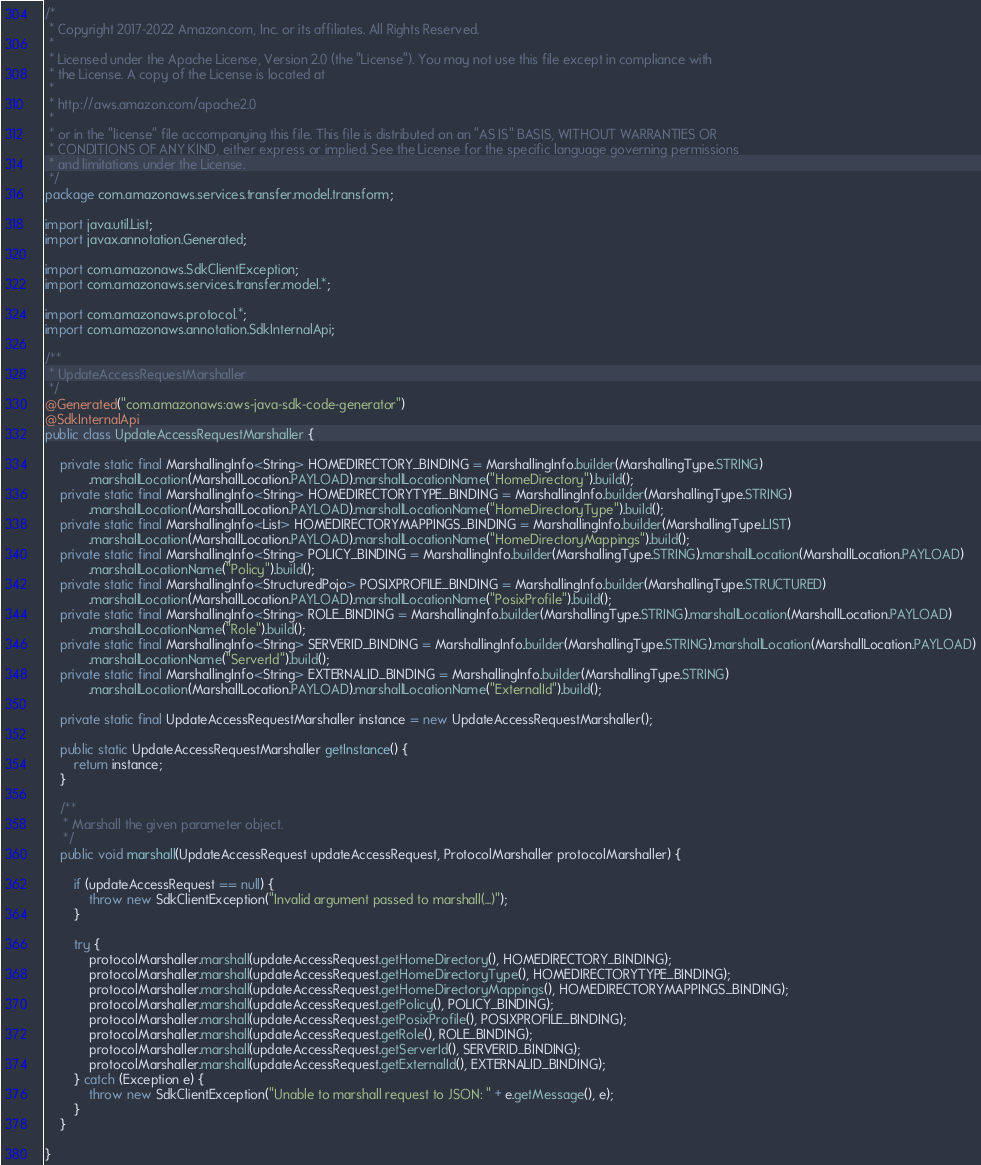<code> <loc_0><loc_0><loc_500><loc_500><_Java_>/*
 * Copyright 2017-2022 Amazon.com, Inc. or its affiliates. All Rights Reserved.
 * 
 * Licensed under the Apache License, Version 2.0 (the "License"). You may not use this file except in compliance with
 * the License. A copy of the License is located at
 * 
 * http://aws.amazon.com/apache2.0
 * 
 * or in the "license" file accompanying this file. This file is distributed on an "AS IS" BASIS, WITHOUT WARRANTIES OR
 * CONDITIONS OF ANY KIND, either express or implied. See the License for the specific language governing permissions
 * and limitations under the License.
 */
package com.amazonaws.services.transfer.model.transform;

import java.util.List;
import javax.annotation.Generated;

import com.amazonaws.SdkClientException;
import com.amazonaws.services.transfer.model.*;

import com.amazonaws.protocol.*;
import com.amazonaws.annotation.SdkInternalApi;

/**
 * UpdateAccessRequestMarshaller
 */
@Generated("com.amazonaws:aws-java-sdk-code-generator")
@SdkInternalApi
public class UpdateAccessRequestMarshaller {

    private static final MarshallingInfo<String> HOMEDIRECTORY_BINDING = MarshallingInfo.builder(MarshallingType.STRING)
            .marshallLocation(MarshallLocation.PAYLOAD).marshallLocationName("HomeDirectory").build();
    private static final MarshallingInfo<String> HOMEDIRECTORYTYPE_BINDING = MarshallingInfo.builder(MarshallingType.STRING)
            .marshallLocation(MarshallLocation.PAYLOAD).marshallLocationName("HomeDirectoryType").build();
    private static final MarshallingInfo<List> HOMEDIRECTORYMAPPINGS_BINDING = MarshallingInfo.builder(MarshallingType.LIST)
            .marshallLocation(MarshallLocation.PAYLOAD).marshallLocationName("HomeDirectoryMappings").build();
    private static final MarshallingInfo<String> POLICY_BINDING = MarshallingInfo.builder(MarshallingType.STRING).marshallLocation(MarshallLocation.PAYLOAD)
            .marshallLocationName("Policy").build();
    private static final MarshallingInfo<StructuredPojo> POSIXPROFILE_BINDING = MarshallingInfo.builder(MarshallingType.STRUCTURED)
            .marshallLocation(MarshallLocation.PAYLOAD).marshallLocationName("PosixProfile").build();
    private static final MarshallingInfo<String> ROLE_BINDING = MarshallingInfo.builder(MarshallingType.STRING).marshallLocation(MarshallLocation.PAYLOAD)
            .marshallLocationName("Role").build();
    private static final MarshallingInfo<String> SERVERID_BINDING = MarshallingInfo.builder(MarshallingType.STRING).marshallLocation(MarshallLocation.PAYLOAD)
            .marshallLocationName("ServerId").build();
    private static final MarshallingInfo<String> EXTERNALID_BINDING = MarshallingInfo.builder(MarshallingType.STRING)
            .marshallLocation(MarshallLocation.PAYLOAD).marshallLocationName("ExternalId").build();

    private static final UpdateAccessRequestMarshaller instance = new UpdateAccessRequestMarshaller();

    public static UpdateAccessRequestMarshaller getInstance() {
        return instance;
    }

    /**
     * Marshall the given parameter object.
     */
    public void marshall(UpdateAccessRequest updateAccessRequest, ProtocolMarshaller protocolMarshaller) {

        if (updateAccessRequest == null) {
            throw new SdkClientException("Invalid argument passed to marshall(...)");
        }

        try {
            protocolMarshaller.marshall(updateAccessRequest.getHomeDirectory(), HOMEDIRECTORY_BINDING);
            protocolMarshaller.marshall(updateAccessRequest.getHomeDirectoryType(), HOMEDIRECTORYTYPE_BINDING);
            protocolMarshaller.marshall(updateAccessRequest.getHomeDirectoryMappings(), HOMEDIRECTORYMAPPINGS_BINDING);
            protocolMarshaller.marshall(updateAccessRequest.getPolicy(), POLICY_BINDING);
            protocolMarshaller.marshall(updateAccessRequest.getPosixProfile(), POSIXPROFILE_BINDING);
            protocolMarshaller.marshall(updateAccessRequest.getRole(), ROLE_BINDING);
            protocolMarshaller.marshall(updateAccessRequest.getServerId(), SERVERID_BINDING);
            protocolMarshaller.marshall(updateAccessRequest.getExternalId(), EXTERNALID_BINDING);
        } catch (Exception e) {
            throw new SdkClientException("Unable to marshall request to JSON: " + e.getMessage(), e);
        }
    }

}
</code> 